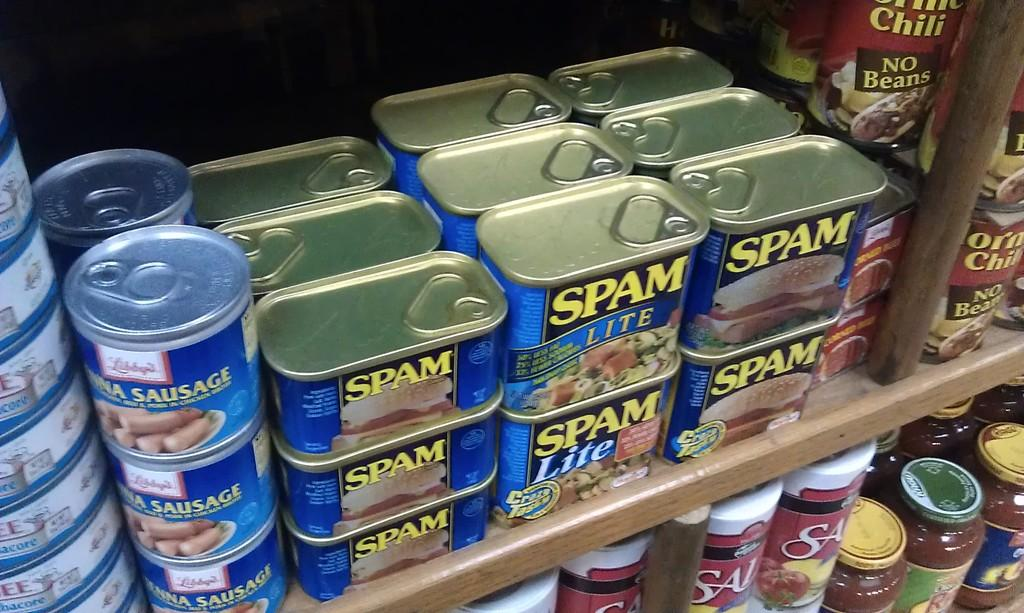<image>
Render a clear and concise summary of the photo. Many cans of spam are stacked on a shelf in a store. 